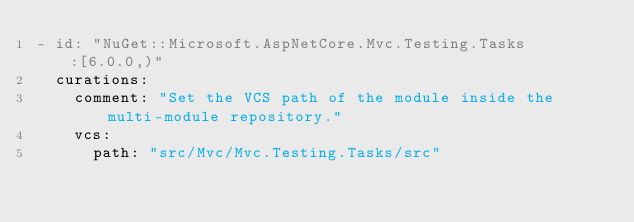Convert code to text. <code><loc_0><loc_0><loc_500><loc_500><_YAML_>- id: "NuGet::Microsoft.AspNetCore.Mvc.Testing.Tasks:[6.0.0,)"
  curations:
    comment: "Set the VCS path of the module inside the multi-module repository."
    vcs:
      path: "src/Mvc/Mvc.Testing.Tasks/src"
</code> 